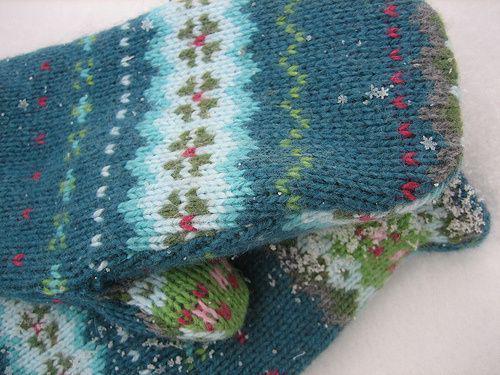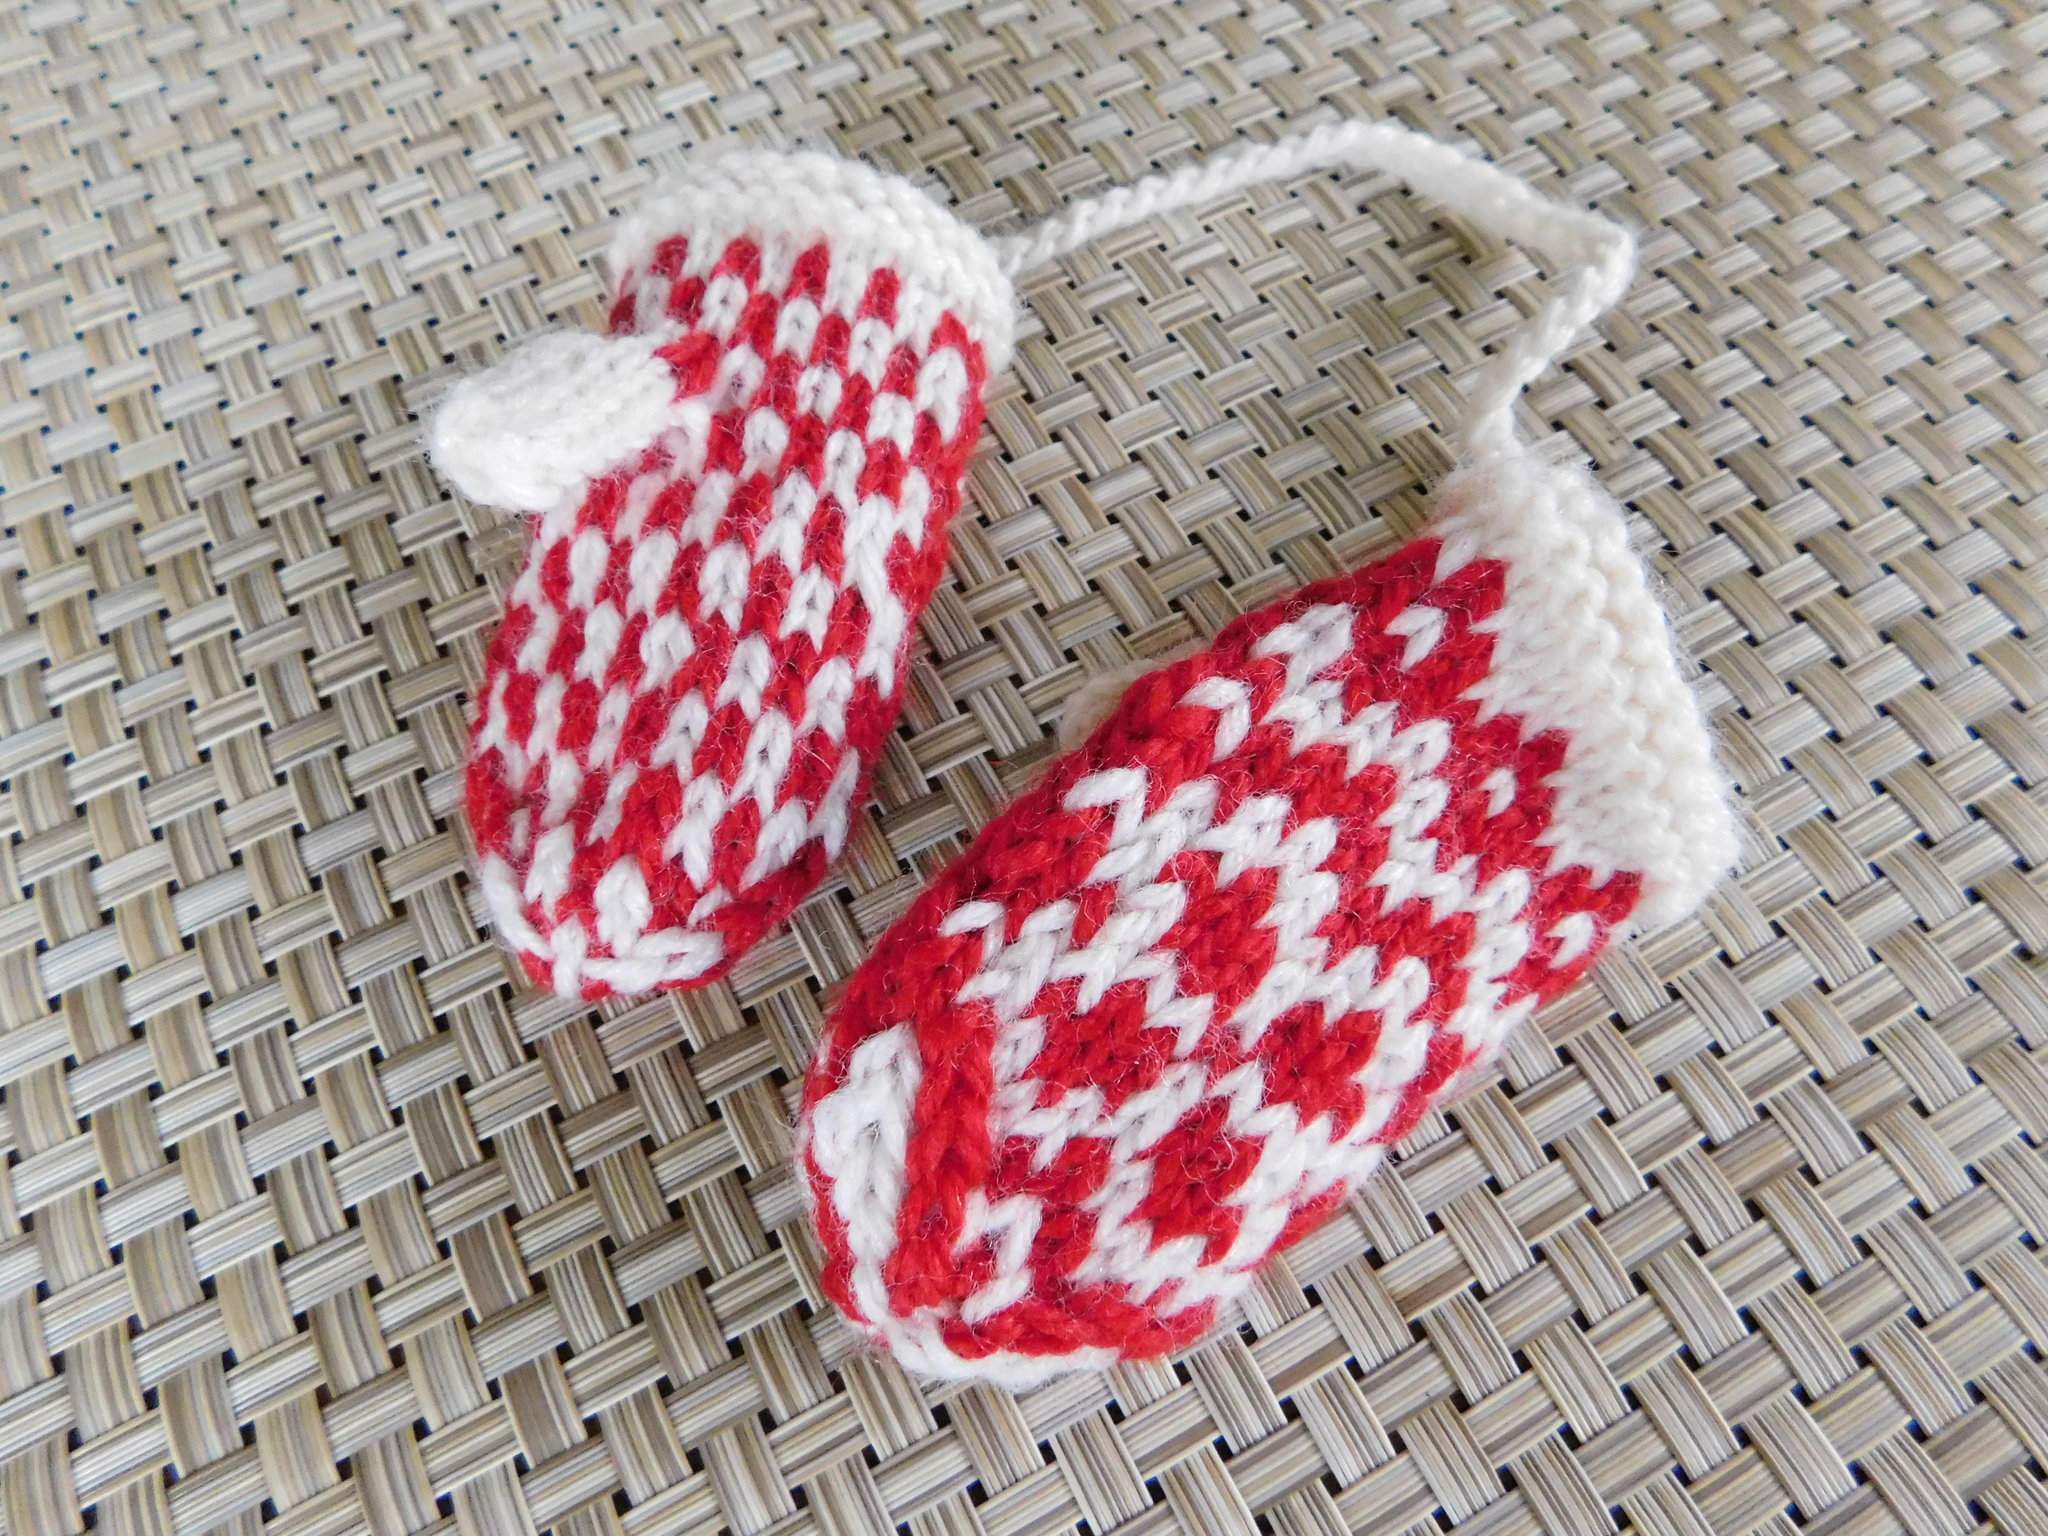The first image is the image on the left, the second image is the image on the right. For the images displayed, is the sentence "One image had a clear,wooden background surface." factually correct? Answer yes or no. No. The first image is the image on the left, the second image is the image on the right. Given the left and right images, does the statement "At least one pair of mittens features a pointed, triangular shaped top, rather than a rounded one." hold true? Answer yes or no. No. 